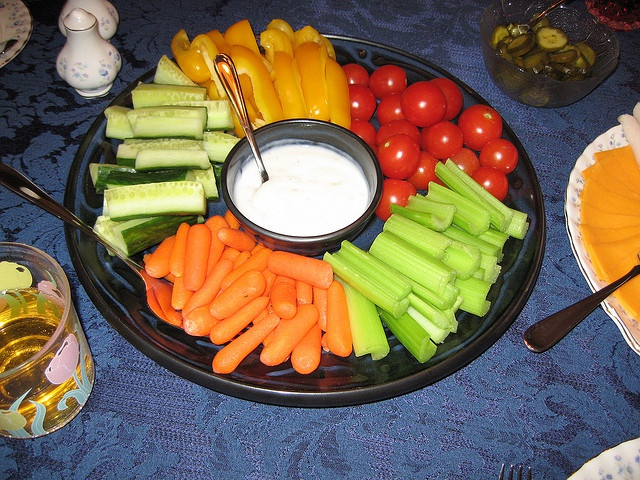Describe the objects in this image and their specific colors. I can see dining table in black, gray, orange, and navy tones, bowl in brown, white, gray, black, and darkgray tones, cup in brown, olive, maroon, and gray tones, bowl in brown, black, and olive tones, and carrot in brown, red, orange, and black tones in this image. 